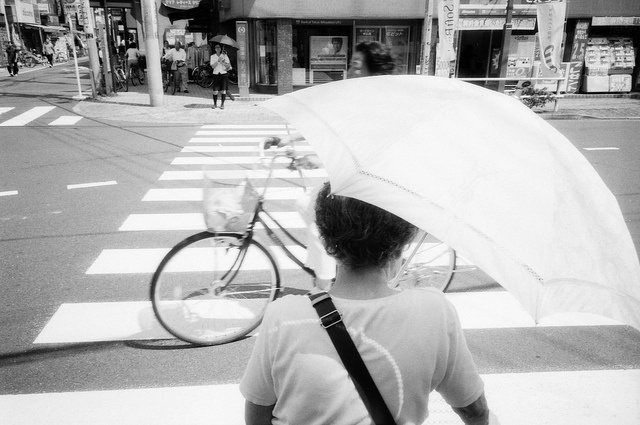Describe the objects in this image and their specific colors. I can see umbrella in darkgray, white, gray, and black tones, people in darkgray, lightgray, black, and gray tones, bicycle in darkgray, lightgray, gray, and black tones, handbag in darkgray, black, gray, and lightgray tones, and people in black, gray, and darkgray tones in this image. 